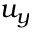Convert formula to latex. <formula><loc_0><loc_0><loc_500><loc_500>u _ { y }</formula> 